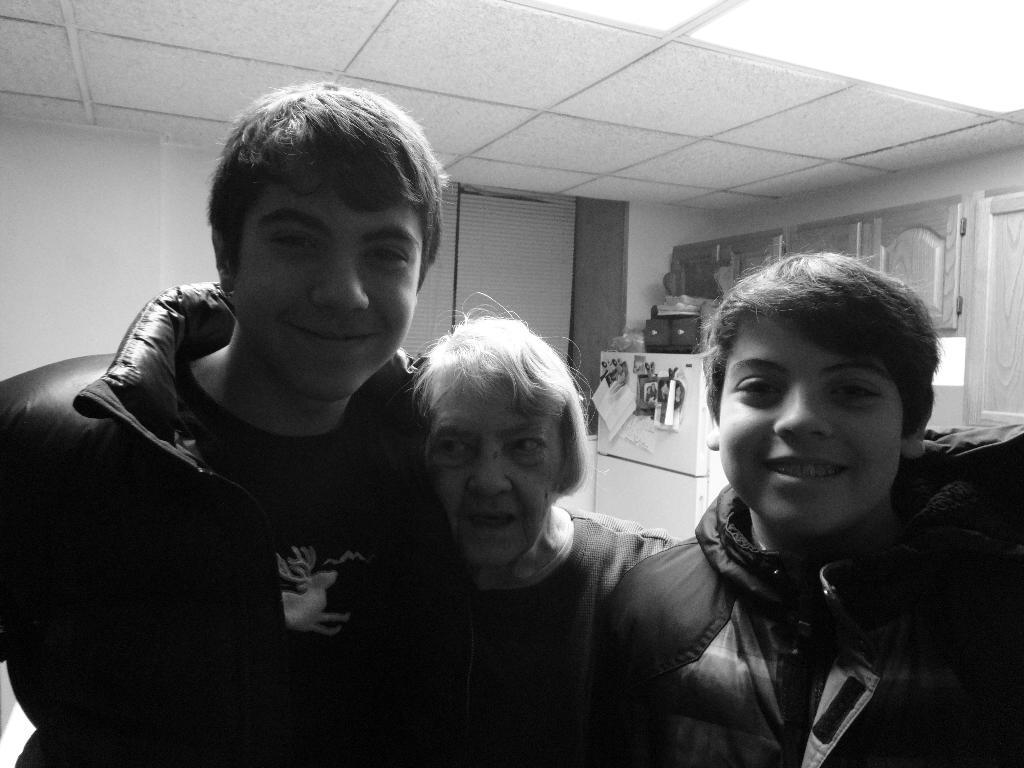What is the color scheme of the image? The image is black and white. How many people are in the front of the image? There are three people standing in the front of the image. What are the people doing in the image? The people are posing for a photo. What type of appliance can be seen in the image? There is a refrigerator visible in the image. What type of furniture is present in the image? There are cupboards in the image. Can you describe how the people are jumping in the image? There is no jumping depicted in the image; the people are standing and posing for a photo. What type of turn is being performed by the people in the image? There is no turning or dancing activity shown in the image; the people are standing and posing for a photo. 